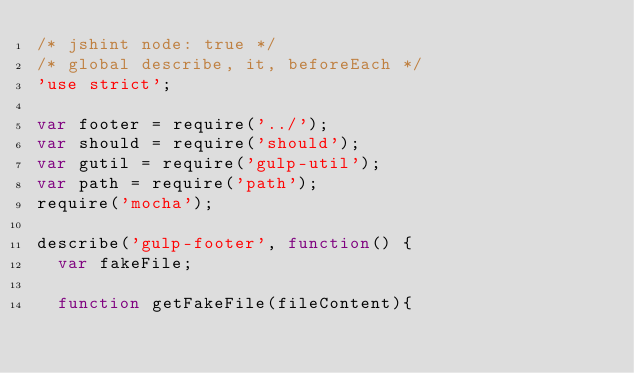Convert code to text. <code><loc_0><loc_0><loc_500><loc_500><_JavaScript_>/* jshint node: true */
/* global describe, it, beforeEach */
'use strict';

var footer = require('../');
var should = require('should');
var gutil = require('gulp-util');
var path = require('path');
require('mocha');

describe('gulp-footer', function() {
  var fakeFile;

  function getFakeFile(fileContent){</code> 